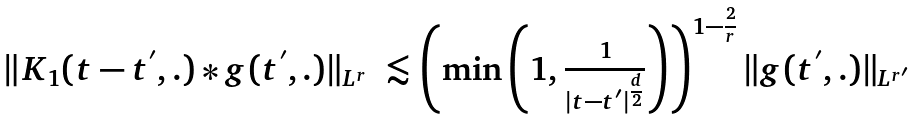Convert formula to latex. <formula><loc_0><loc_0><loc_500><loc_500>\begin{array} { l l } \| K _ { 1 } ( t - t ^ { ^ { \prime } } , . ) \ast g ( t ^ { ^ { \prime } } , . ) \| _ { L ^ { r } } & \lesssim \left ( \min { \left ( 1 , \frac { 1 } { | t - t ^ { ^ { \prime } } | ^ { \frac { d } { 2 } } } \right ) } \right ) ^ { 1 - \frac { 2 } { r } } \| g ( t ^ { ^ { \prime } } , . ) \| _ { L ^ { r { ^ { \prime } } } } \end{array}</formula> 